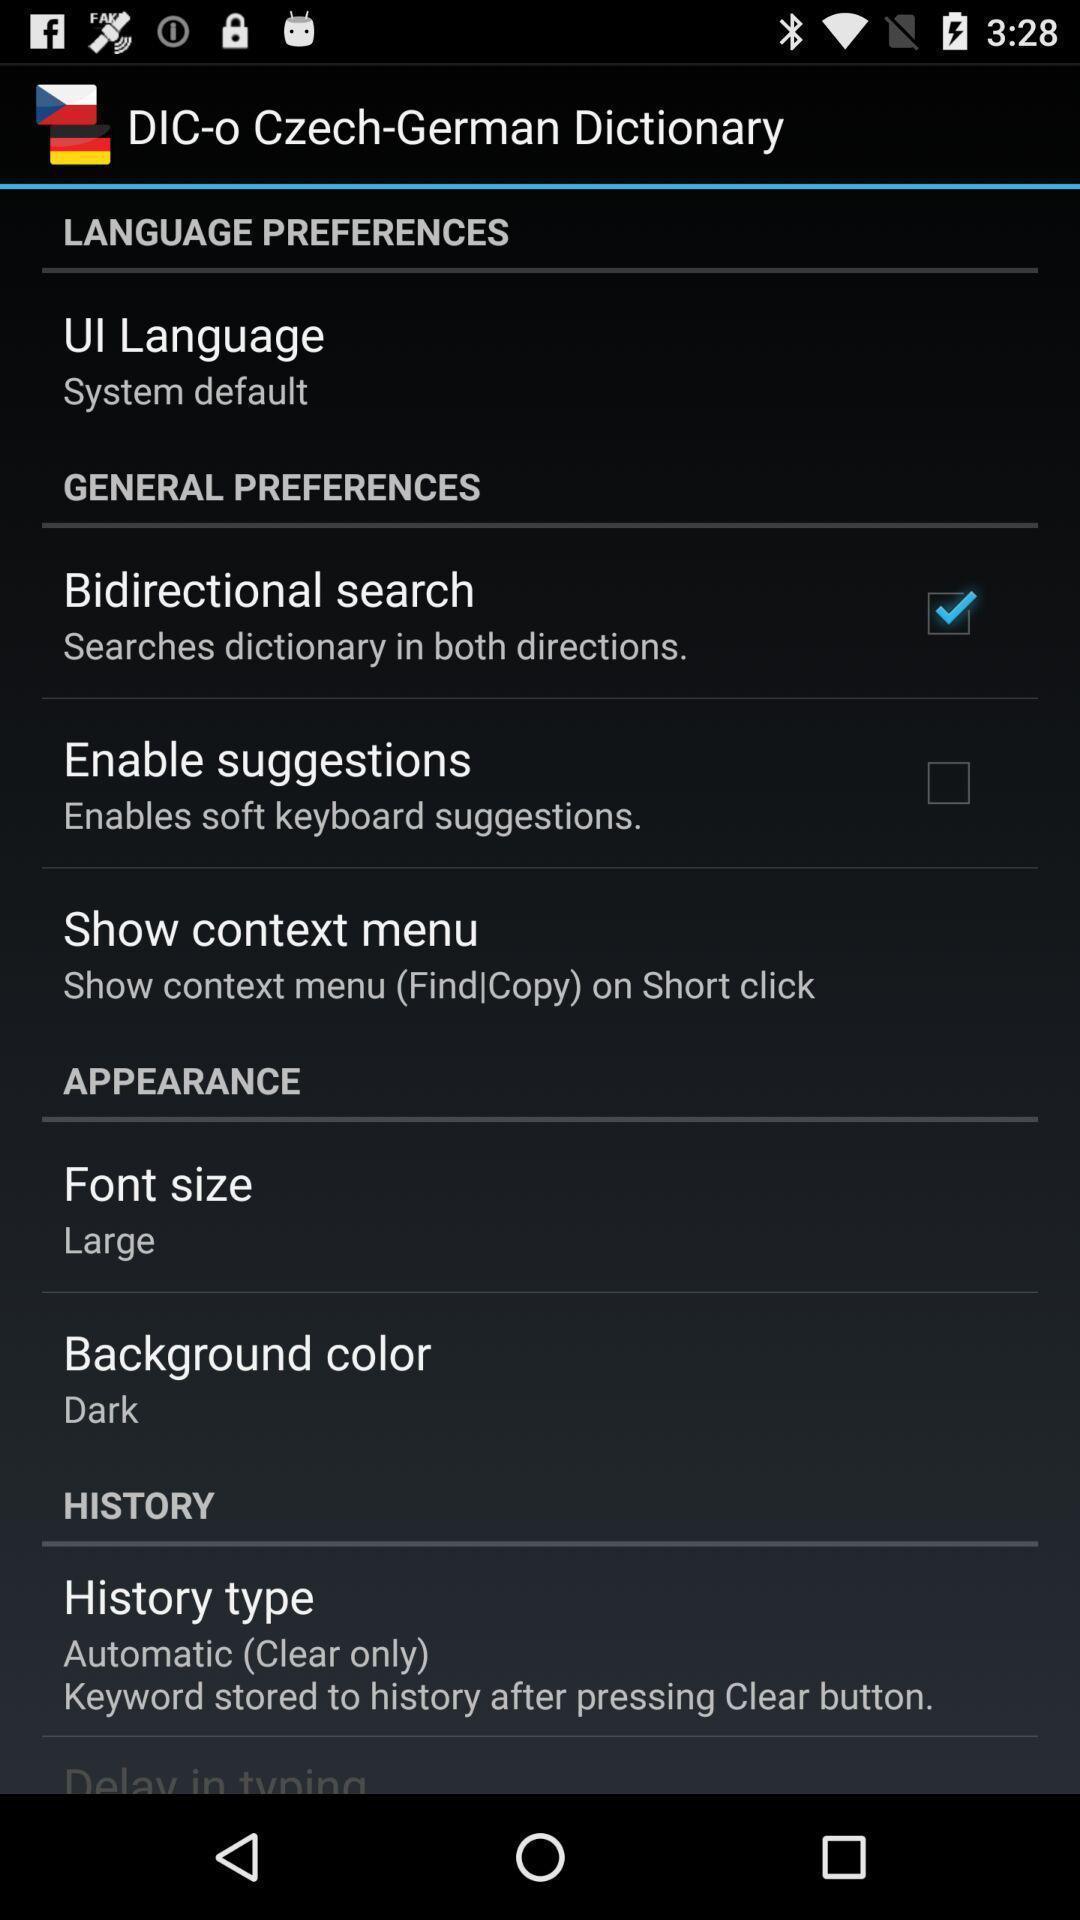What is the overall content of this screenshot? Settings page of a dictionary app. 